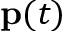<formula> <loc_0><loc_0><loc_500><loc_500>\mathbf p ( t )</formula> 